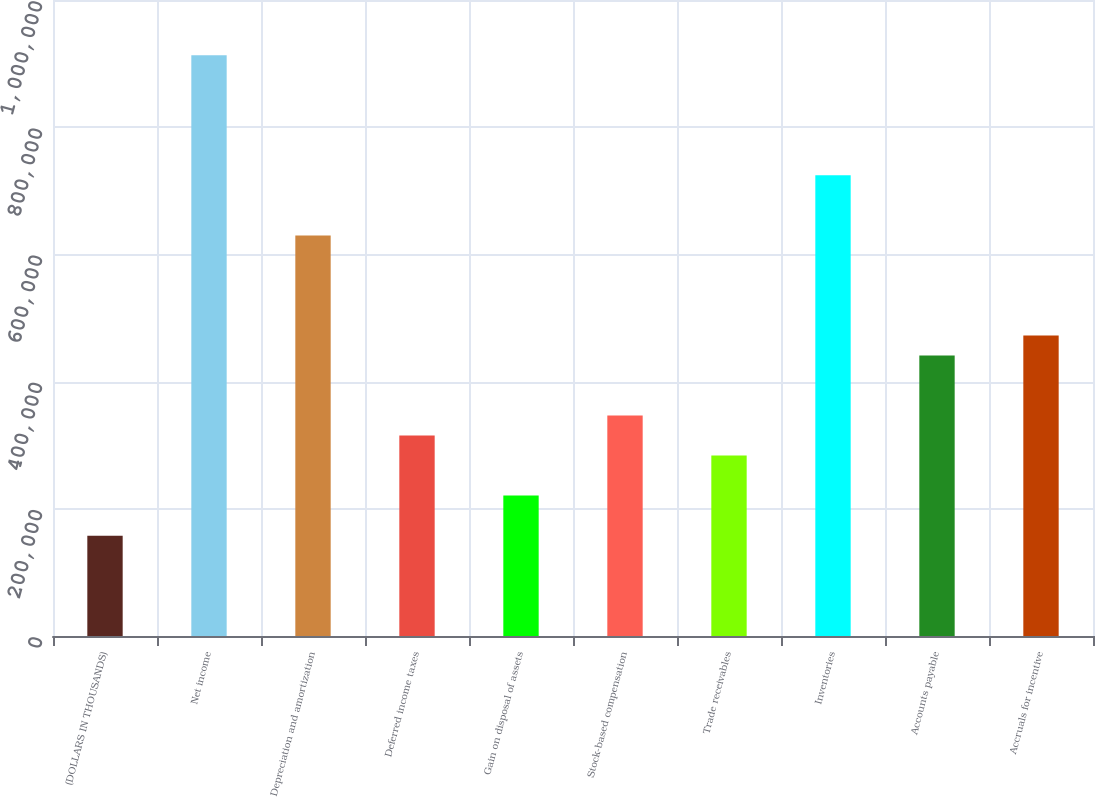Convert chart to OTSL. <chart><loc_0><loc_0><loc_500><loc_500><bar_chart><fcel>(DOLLARS IN THOUSANDS)<fcel>Net income<fcel>Depreciation and amortization<fcel>Deferred income taxes<fcel>Gain on disposal of assets<fcel>Stock-based compensation<fcel>Trade receivables<fcel>Inventories<fcel>Accounts payable<fcel>Accruals for incentive<nl><fcel>157774<fcel>913112<fcel>629860<fcel>315136<fcel>220719<fcel>346608<fcel>283664<fcel>724277<fcel>441026<fcel>472498<nl></chart> 